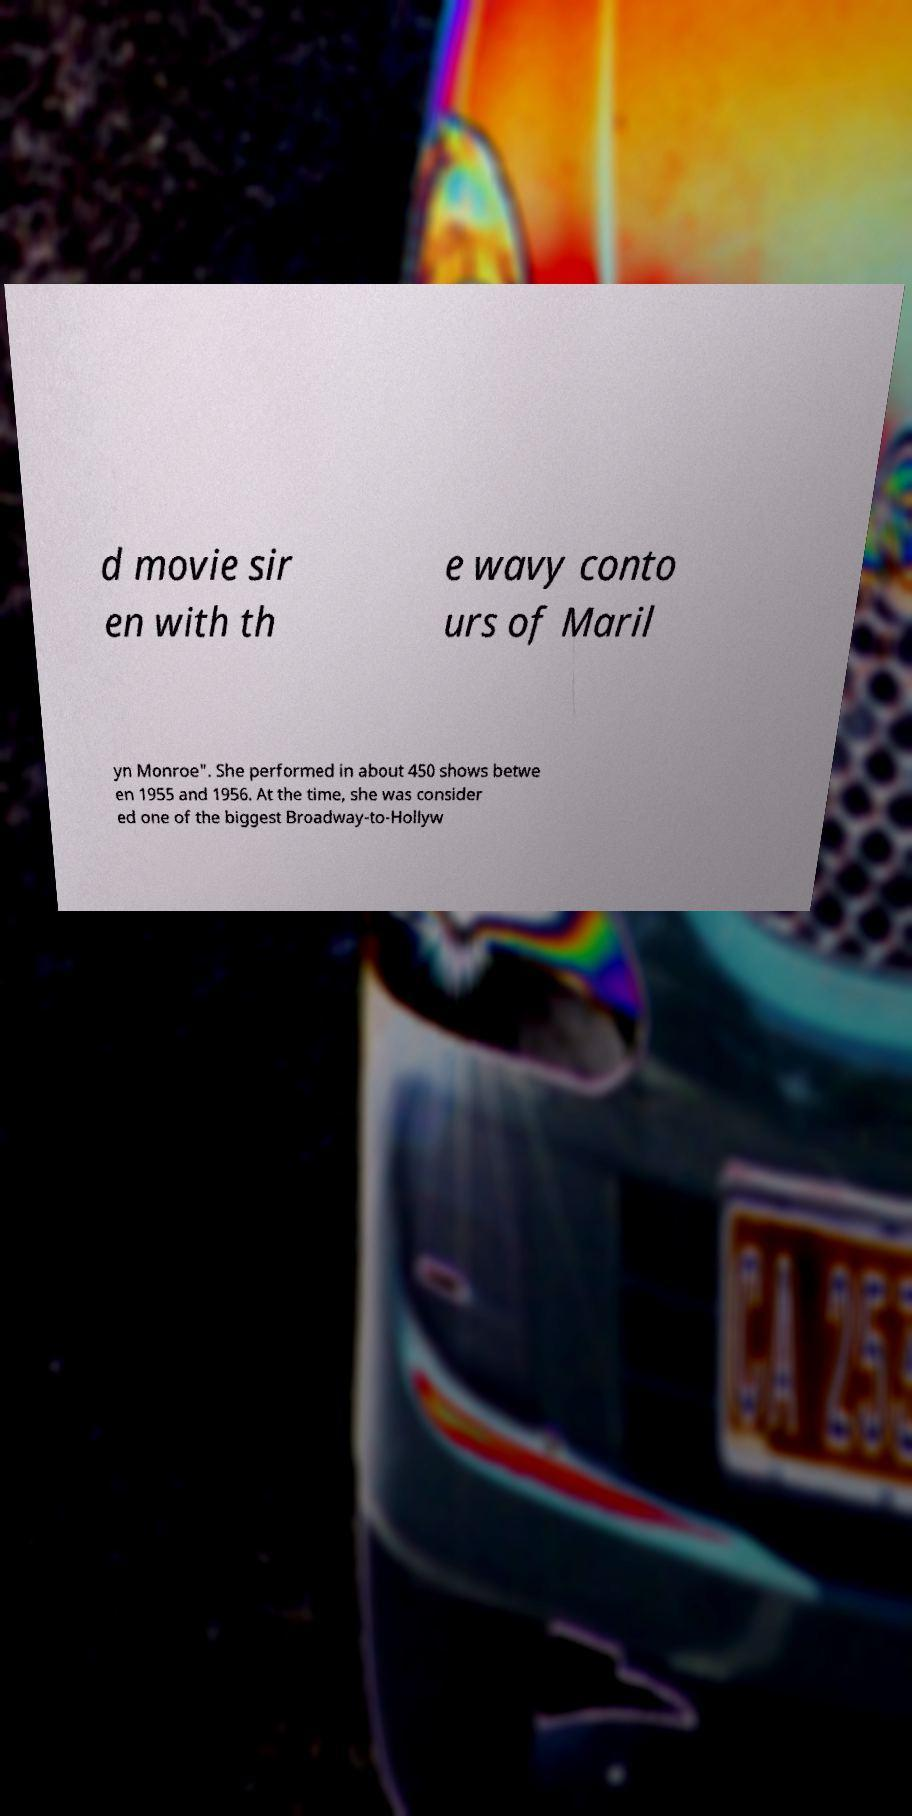Could you extract and type out the text from this image? d movie sir en with th e wavy conto urs of Maril yn Monroe". She performed in about 450 shows betwe en 1955 and 1956. At the time, she was consider ed one of the biggest Broadway-to-Hollyw 